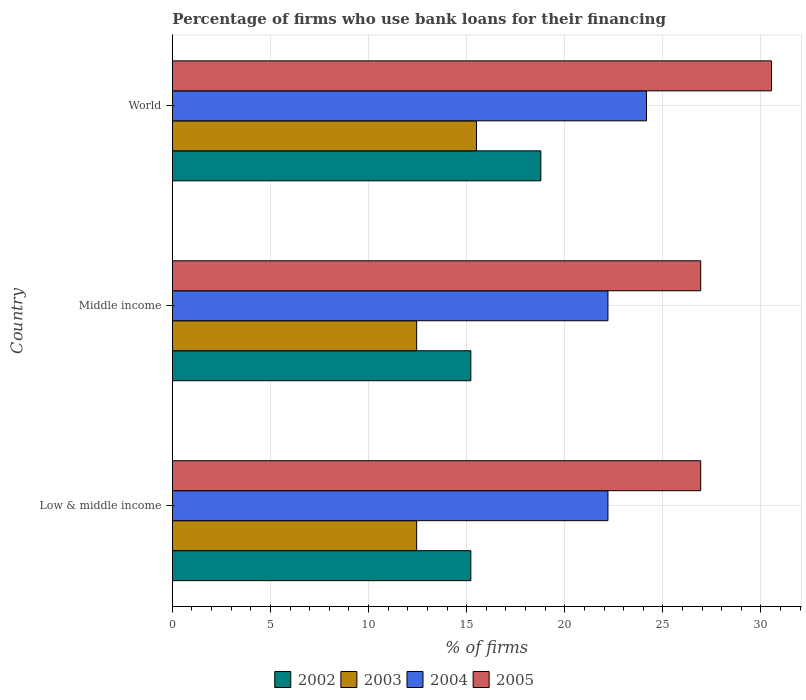How many different coloured bars are there?
Keep it short and to the point. 4. How many bars are there on the 2nd tick from the top?
Provide a succinct answer. 4. How many bars are there on the 1st tick from the bottom?
Provide a short and direct response. 4. In how many cases, is the number of bars for a given country not equal to the number of legend labels?
Your response must be concise. 0. What is the percentage of firms who use bank loans for their financing in 2004 in World?
Your response must be concise. 24.17. Across all countries, what is the minimum percentage of firms who use bank loans for their financing in 2003?
Make the answer very short. 12.45. In which country was the percentage of firms who use bank loans for their financing in 2003 maximum?
Your answer should be very brief. World. In which country was the percentage of firms who use bank loans for their financing in 2004 minimum?
Offer a very short reply. Low & middle income. What is the total percentage of firms who use bank loans for their financing in 2003 in the graph?
Your answer should be compact. 40.4. What is the difference between the percentage of firms who use bank loans for their financing in 2005 in Low & middle income and that in World?
Keep it short and to the point. -3.61. What is the difference between the percentage of firms who use bank loans for their financing in 2004 in Middle income and the percentage of firms who use bank loans for their financing in 2003 in World?
Keep it short and to the point. 6.7. What is the average percentage of firms who use bank loans for their financing in 2005 per country?
Your answer should be very brief. 28.13. What is the difference between the percentage of firms who use bank loans for their financing in 2004 and percentage of firms who use bank loans for their financing in 2005 in Middle income?
Your answer should be compact. -4.73. What is the ratio of the percentage of firms who use bank loans for their financing in 2002 in Low & middle income to that in World?
Your answer should be very brief. 0.81. Is the difference between the percentage of firms who use bank loans for their financing in 2004 in Low & middle income and World greater than the difference between the percentage of firms who use bank loans for their financing in 2005 in Low & middle income and World?
Offer a very short reply. Yes. What is the difference between the highest and the second highest percentage of firms who use bank loans for their financing in 2002?
Offer a very short reply. 3.57. What is the difference between the highest and the lowest percentage of firms who use bank loans for their financing in 2005?
Give a very brief answer. 3.61. In how many countries, is the percentage of firms who use bank loans for their financing in 2002 greater than the average percentage of firms who use bank loans for their financing in 2002 taken over all countries?
Provide a succinct answer. 1. Is the sum of the percentage of firms who use bank loans for their financing in 2005 in Low & middle income and World greater than the maximum percentage of firms who use bank loans for their financing in 2004 across all countries?
Provide a short and direct response. Yes. Is it the case that in every country, the sum of the percentage of firms who use bank loans for their financing in 2002 and percentage of firms who use bank loans for their financing in 2005 is greater than the sum of percentage of firms who use bank loans for their financing in 2003 and percentage of firms who use bank loans for their financing in 2004?
Provide a succinct answer. No. What does the 3rd bar from the top in World represents?
Offer a terse response. 2003. What does the 2nd bar from the bottom in World represents?
Keep it short and to the point. 2003. Is it the case that in every country, the sum of the percentage of firms who use bank loans for their financing in 2005 and percentage of firms who use bank loans for their financing in 2003 is greater than the percentage of firms who use bank loans for their financing in 2002?
Keep it short and to the point. Yes. How many countries are there in the graph?
Your answer should be very brief. 3. Are the values on the major ticks of X-axis written in scientific E-notation?
Provide a short and direct response. No. How are the legend labels stacked?
Offer a very short reply. Horizontal. What is the title of the graph?
Make the answer very short. Percentage of firms who use bank loans for their financing. Does "1990" appear as one of the legend labels in the graph?
Offer a terse response. No. What is the label or title of the X-axis?
Provide a succinct answer. % of firms. What is the label or title of the Y-axis?
Provide a succinct answer. Country. What is the % of firms in 2002 in Low & middle income?
Make the answer very short. 15.21. What is the % of firms of 2003 in Low & middle income?
Provide a succinct answer. 12.45. What is the % of firms of 2004 in Low & middle income?
Give a very brief answer. 22.2. What is the % of firms of 2005 in Low & middle income?
Your response must be concise. 26.93. What is the % of firms in 2002 in Middle income?
Offer a very short reply. 15.21. What is the % of firms in 2003 in Middle income?
Your response must be concise. 12.45. What is the % of firms in 2005 in Middle income?
Offer a very short reply. 26.93. What is the % of firms in 2002 in World?
Your response must be concise. 18.78. What is the % of firms in 2004 in World?
Make the answer very short. 24.17. What is the % of firms in 2005 in World?
Keep it short and to the point. 30.54. Across all countries, what is the maximum % of firms in 2002?
Provide a short and direct response. 18.78. Across all countries, what is the maximum % of firms in 2004?
Provide a short and direct response. 24.17. Across all countries, what is the maximum % of firms of 2005?
Provide a short and direct response. 30.54. Across all countries, what is the minimum % of firms in 2002?
Ensure brevity in your answer.  15.21. Across all countries, what is the minimum % of firms of 2003?
Your answer should be compact. 12.45. Across all countries, what is the minimum % of firms in 2005?
Provide a short and direct response. 26.93. What is the total % of firms in 2002 in the graph?
Your answer should be very brief. 49.21. What is the total % of firms in 2003 in the graph?
Provide a succinct answer. 40.4. What is the total % of firms of 2004 in the graph?
Your response must be concise. 68.57. What is the total % of firms in 2005 in the graph?
Your response must be concise. 84.39. What is the difference between the % of firms in 2003 in Low & middle income and that in Middle income?
Your answer should be very brief. 0. What is the difference between the % of firms in 2002 in Low & middle income and that in World?
Offer a terse response. -3.57. What is the difference between the % of firms in 2003 in Low & middle income and that in World?
Keep it short and to the point. -3.05. What is the difference between the % of firms in 2004 in Low & middle income and that in World?
Ensure brevity in your answer.  -1.97. What is the difference between the % of firms in 2005 in Low & middle income and that in World?
Offer a very short reply. -3.61. What is the difference between the % of firms of 2002 in Middle income and that in World?
Provide a short and direct response. -3.57. What is the difference between the % of firms of 2003 in Middle income and that in World?
Give a very brief answer. -3.05. What is the difference between the % of firms of 2004 in Middle income and that in World?
Your answer should be compact. -1.97. What is the difference between the % of firms in 2005 in Middle income and that in World?
Your answer should be compact. -3.61. What is the difference between the % of firms of 2002 in Low & middle income and the % of firms of 2003 in Middle income?
Your answer should be very brief. 2.76. What is the difference between the % of firms in 2002 in Low & middle income and the % of firms in 2004 in Middle income?
Offer a very short reply. -6.99. What is the difference between the % of firms of 2002 in Low & middle income and the % of firms of 2005 in Middle income?
Your answer should be very brief. -11.72. What is the difference between the % of firms of 2003 in Low & middle income and the % of firms of 2004 in Middle income?
Offer a terse response. -9.75. What is the difference between the % of firms of 2003 in Low & middle income and the % of firms of 2005 in Middle income?
Offer a terse response. -14.48. What is the difference between the % of firms in 2004 in Low & middle income and the % of firms in 2005 in Middle income?
Provide a short and direct response. -4.73. What is the difference between the % of firms of 2002 in Low & middle income and the % of firms of 2003 in World?
Your answer should be compact. -0.29. What is the difference between the % of firms of 2002 in Low & middle income and the % of firms of 2004 in World?
Provide a short and direct response. -8.95. What is the difference between the % of firms of 2002 in Low & middle income and the % of firms of 2005 in World?
Give a very brief answer. -15.33. What is the difference between the % of firms of 2003 in Low & middle income and the % of firms of 2004 in World?
Offer a terse response. -11.72. What is the difference between the % of firms in 2003 in Low & middle income and the % of firms in 2005 in World?
Give a very brief answer. -18.09. What is the difference between the % of firms of 2004 in Low & middle income and the % of firms of 2005 in World?
Give a very brief answer. -8.34. What is the difference between the % of firms of 2002 in Middle income and the % of firms of 2003 in World?
Offer a terse response. -0.29. What is the difference between the % of firms in 2002 in Middle income and the % of firms in 2004 in World?
Make the answer very short. -8.95. What is the difference between the % of firms in 2002 in Middle income and the % of firms in 2005 in World?
Make the answer very short. -15.33. What is the difference between the % of firms in 2003 in Middle income and the % of firms in 2004 in World?
Offer a terse response. -11.72. What is the difference between the % of firms in 2003 in Middle income and the % of firms in 2005 in World?
Your response must be concise. -18.09. What is the difference between the % of firms in 2004 in Middle income and the % of firms in 2005 in World?
Offer a terse response. -8.34. What is the average % of firms in 2002 per country?
Ensure brevity in your answer.  16.4. What is the average % of firms in 2003 per country?
Provide a short and direct response. 13.47. What is the average % of firms in 2004 per country?
Offer a very short reply. 22.86. What is the average % of firms of 2005 per country?
Ensure brevity in your answer.  28.13. What is the difference between the % of firms of 2002 and % of firms of 2003 in Low & middle income?
Make the answer very short. 2.76. What is the difference between the % of firms in 2002 and % of firms in 2004 in Low & middle income?
Your answer should be very brief. -6.99. What is the difference between the % of firms in 2002 and % of firms in 2005 in Low & middle income?
Keep it short and to the point. -11.72. What is the difference between the % of firms in 2003 and % of firms in 2004 in Low & middle income?
Your response must be concise. -9.75. What is the difference between the % of firms in 2003 and % of firms in 2005 in Low & middle income?
Provide a short and direct response. -14.48. What is the difference between the % of firms of 2004 and % of firms of 2005 in Low & middle income?
Give a very brief answer. -4.73. What is the difference between the % of firms of 2002 and % of firms of 2003 in Middle income?
Ensure brevity in your answer.  2.76. What is the difference between the % of firms of 2002 and % of firms of 2004 in Middle income?
Give a very brief answer. -6.99. What is the difference between the % of firms of 2002 and % of firms of 2005 in Middle income?
Keep it short and to the point. -11.72. What is the difference between the % of firms of 2003 and % of firms of 2004 in Middle income?
Your response must be concise. -9.75. What is the difference between the % of firms in 2003 and % of firms in 2005 in Middle income?
Keep it short and to the point. -14.48. What is the difference between the % of firms of 2004 and % of firms of 2005 in Middle income?
Your answer should be compact. -4.73. What is the difference between the % of firms in 2002 and % of firms in 2003 in World?
Make the answer very short. 3.28. What is the difference between the % of firms of 2002 and % of firms of 2004 in World?
Provide a succinct answer. -5.39. What is the difference between the % of firms of 2002 and % of firms of 2005 in World?
Provide a succinct answer. -11.76. What is the difference between the % of firms in 2003 and % of firms in 2004 in World?
Offer a very short reply. -8.67. What is the difference between the % of firms in 2003 and % of firms in 2005 in World?
Your answer should be very brief. -15.04. What is the difference between the % of firms of 2004 and % of firms of 2005 in World?
Your answer should be very brief. -6.37. What is the ratio of the % of firms of 2003 in Low & middle income to that in Middle income?
Provide a short and direct response. 1. What is the ratio of the % of firms in 2004 in Low & middle income to that in Middle income?
Offer a terse response. 1. What is the ratio of the % of firms of 2002 in Low & middle income to that in World?
Provide a succinct answer. 0.81. What is the ratio of the % of firms in 2003 in Low & middle income to that in World?
Keep it short and to the point. 0.8. What is the ratio of the % of firms in 2004 in Low & middle income to that in World?
Keep it short and to the point. 0.92. What is the ratio of the % of firms of 2005 in Low & middle income to that in World?
Ensure brevity in your answer.  0.88. What is the ratio of the % of firms in 2002 in Middle income to that in World?
Your answer should be very brief. 0.81. What is the ratio of the % of firms in 2003 in Middle income to that in World?
Make the answer very short. 0.8. What is the ratio of the % of firms of 2004 in Middle income to that in World?
Your answer should be very brief. 0.92. What is the ratio of the % of firms in 2005 in Middle income to that in World?
Your answer should be very brief. 0.88. What is the difference between the highest and the second highest % of firms of 2002?
Offer a terse response. 3.57. What is the difference between the highest and the second highest % of firms in 2003?
Offer a very short reply. 3.05. What is the difference between the highest and the second highest % of firms in 2004?
Give a very brief answer. 1.97. What is the difference between the highest and the second highest % of firms in 2005?
Provide a succinct answer. 3.61. What is the difference between the highest and the lowest % of firms in 2002?
Keep it short and to the point. 3.57. What is the difference between the highest and the lowest % of firms of 2003?
Offer a terse response. 3.05. What is the difference between the highest and the lowest % of firms of 2004?
Your response must be concise. 1.97. What is the difference between the highest and the lowest % of firms of 2005?
Keep it short and to the point. 3.61. 